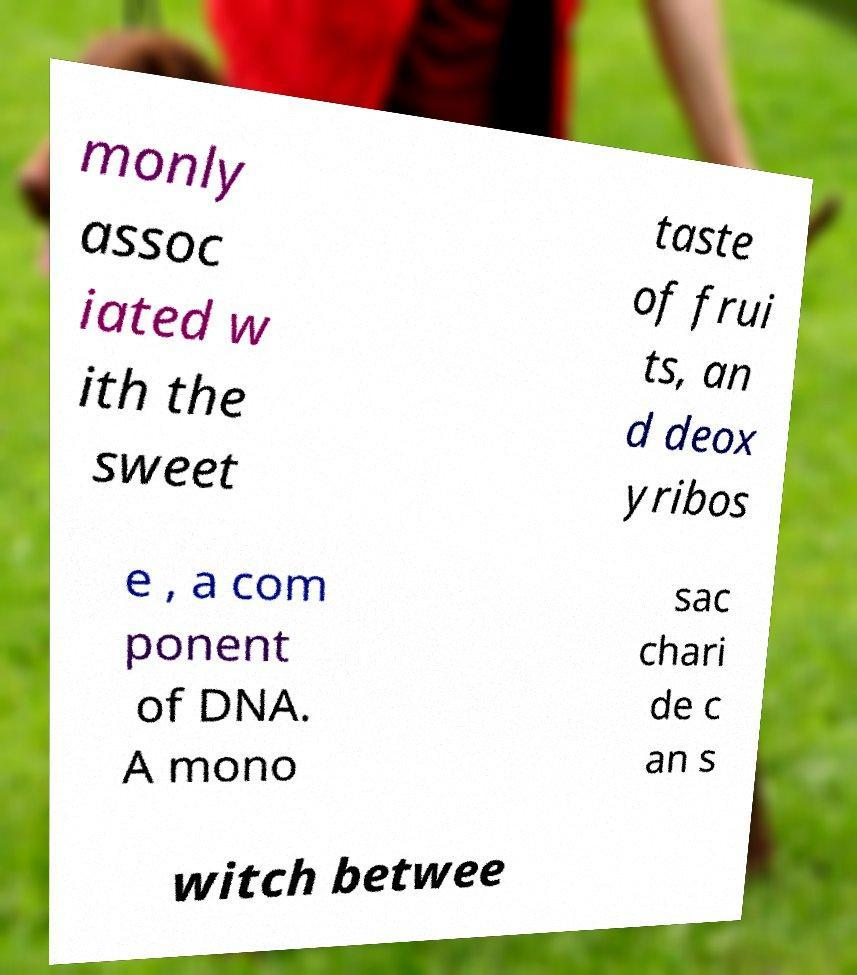What are monosaccharides and their role in human nutrition? Monosaccharides, such as glucose, are the simplest form of carbohydrates and play a critical role in human nutrition. They serve as a primary energy source for our cells, with glucose being particularly important as it's a key energy source for the brain and a metabolic substrate for cellular respiration. Are there any health implications associated with consuming too many monosaccharides? Yes, consuming excessive amounts of monosaccharides, particularly in the form of refined sugars, can lead to various health issues, including weight gain, insulin resistance, and increased risk of type 2 diabetes and cardiovascular diseases. It's essential to balance intake and opt for complex carbohydrates when possible. 